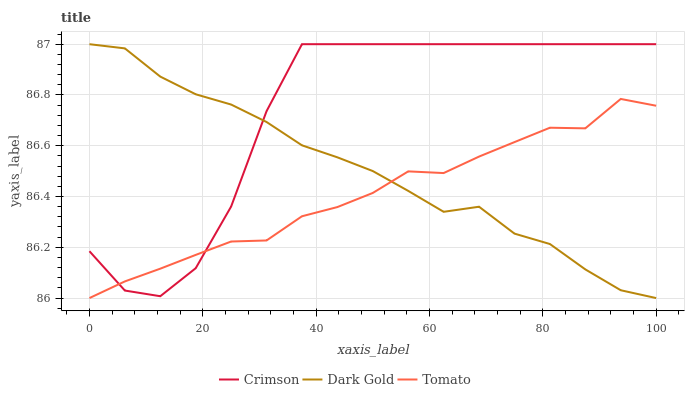Does Tomato have the minimum area under the curve?
Answer yes or no. Yes. Does Dark Gold have the minimum area under the curve?
Answer yes or no. No. Does Dark Gold have the maximum area under the curve?
Answer yes or no. No. Is Crimson the roughest?
Answer yes or no. Yes. Is Tomato the smoothest?
Answer yes or no. No. Is Tomato the roughest?
Answer yes or no. No. Does Tomato have the highest value?
Answer yes or no. No. 